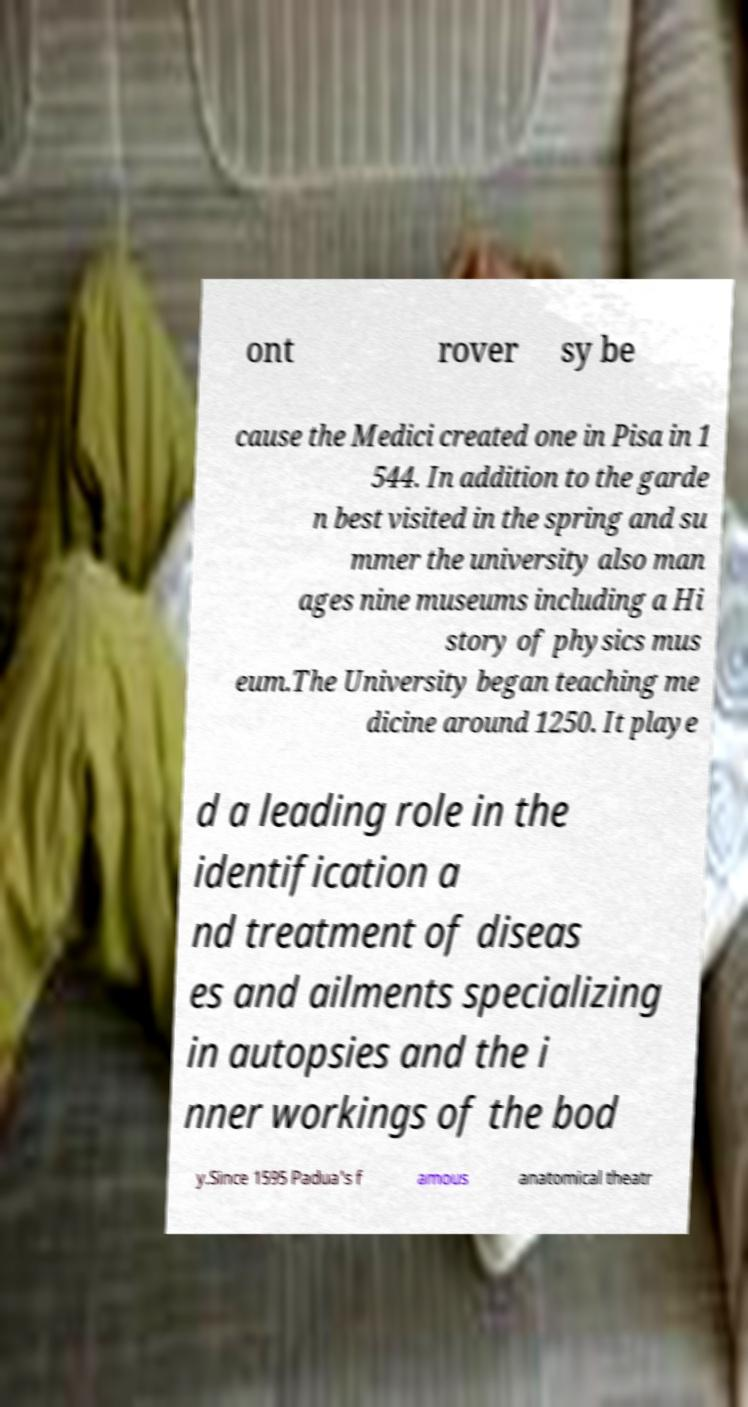Can you accurately transcribe the text from the provided image for me? ont rover sy be cause the Medici created one in Pisa in 1 544. In addition to the garde n best visited in the spring and su mmer the university also man ages nine museums including a Hi story of physics mus eum.The University began teaching me dicine around 1250. It playe d a leading role in the identification a nd treatment of diseas es and ailments specializing in autopsies and the i nner workings of the bod y.Since 1595 Padua's f amous anatomical theatr 